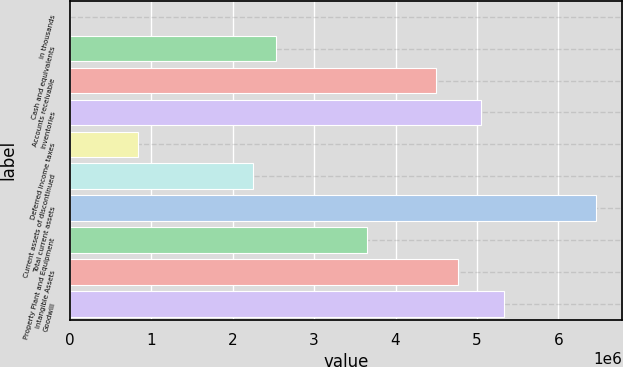Convert chart. <chart><loc_0><loc_0><loc_500><loc_500><bar_chart><fcel>in thousands<fcel>Cash and equivalents<fcel>Accounts receivable<fcel>Inventories<fcel>Deferred income taxes<fcel>Current assets of discontinued<fcel>Total current assets<fcel>Property Plant and Equipment<fcel>Intangible Assets<fcel>Goodwill<nl><fcel>2005<fcel>2.52759e+06<fcel>4.49194e+06<fcel>5.05318e+06<fcel>843867<fcel>2.24697e+06<fcel>6.45628e+06<fcel>3.65008e+06<fcel>4.77256e+06<fcel>5.3338e+06<nl></chart> 